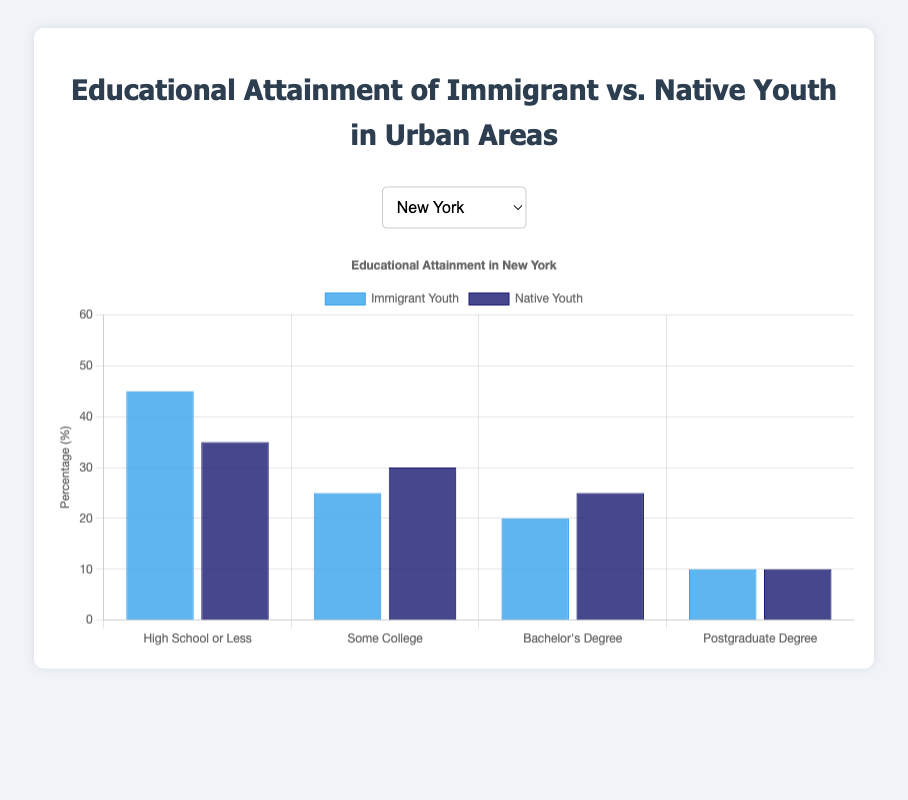What is the educational attainment level with the highest percentage of immigrant youth in New York? Look at the heights of the blue bars for New York, the highest bar represents "High School or Less" at 45%.
Answer: High School or Less Between native youth and immigrant youth, who has a higher percentage of Bachelor’s Degree attainment in Los Angeles? Compare the heights of the bars for "Bachelor's Degree" in Los Angeles, the dark blue bar (native youth) is higher at 20%, compared to 18% for immigrant youth.
Answer: Native Youth What is the difference in the percentage of youth with "Some College" education between immigrant and native youth in Chicago? Locate the "Some College" category for Chicago, subtract the immigrant percentage (24%) from the native percentage (29%).
Answer: 5% Which city has the highest percentage of immigrant youth with "High School or Less" education? Compare the heights of the blue bars for "High School or Less" across all cities, Houston has the highest at 52%.
Answer: Houston Which educational attainment level shows equal percentages for both immigrant and native youth across all cities? Scan each category for all cities and find any categories where the blue and dark blue bars are of equal height: "Postgraduate Degree" in New York and Los Angeles both have 10%.
Answer: Postgraduate Degree in New York and Los Angeles In San Francisco, what is the sum of the percentages of immigrant youth with either "Bachelor's Degree" or "Postgraduate Degree"? Add the percentages for "Bachelor's Degree" (20%) and "Postgraduate Degree" (12%) for immigrant youth in San Francisco.
Answer: 32% In Houston, how much higher is the percentage of immigrant youth with "High School or Less" education compared to native youth with the same level? Subtract the native youth percentage (38%) from the immigrant youth percentage (52%) for "High School or Less" in Houston.
Answer: 14% Which city has the largest gap between immigrant and native youth for any educational attainment level? Identify the largest percentage difference between any paired blue and dark blue bars: Houston's "High School or Less" with a difference of 14%.
Answer: Houston How does the trend of "Postgraduate Degree" attainment compare between immigrant and native youth across the cities? Analyze the heights of the bars for "Postgraduate Degree" in all cities: they are almost equal or very close in every city.
Answer: Similar Trends 